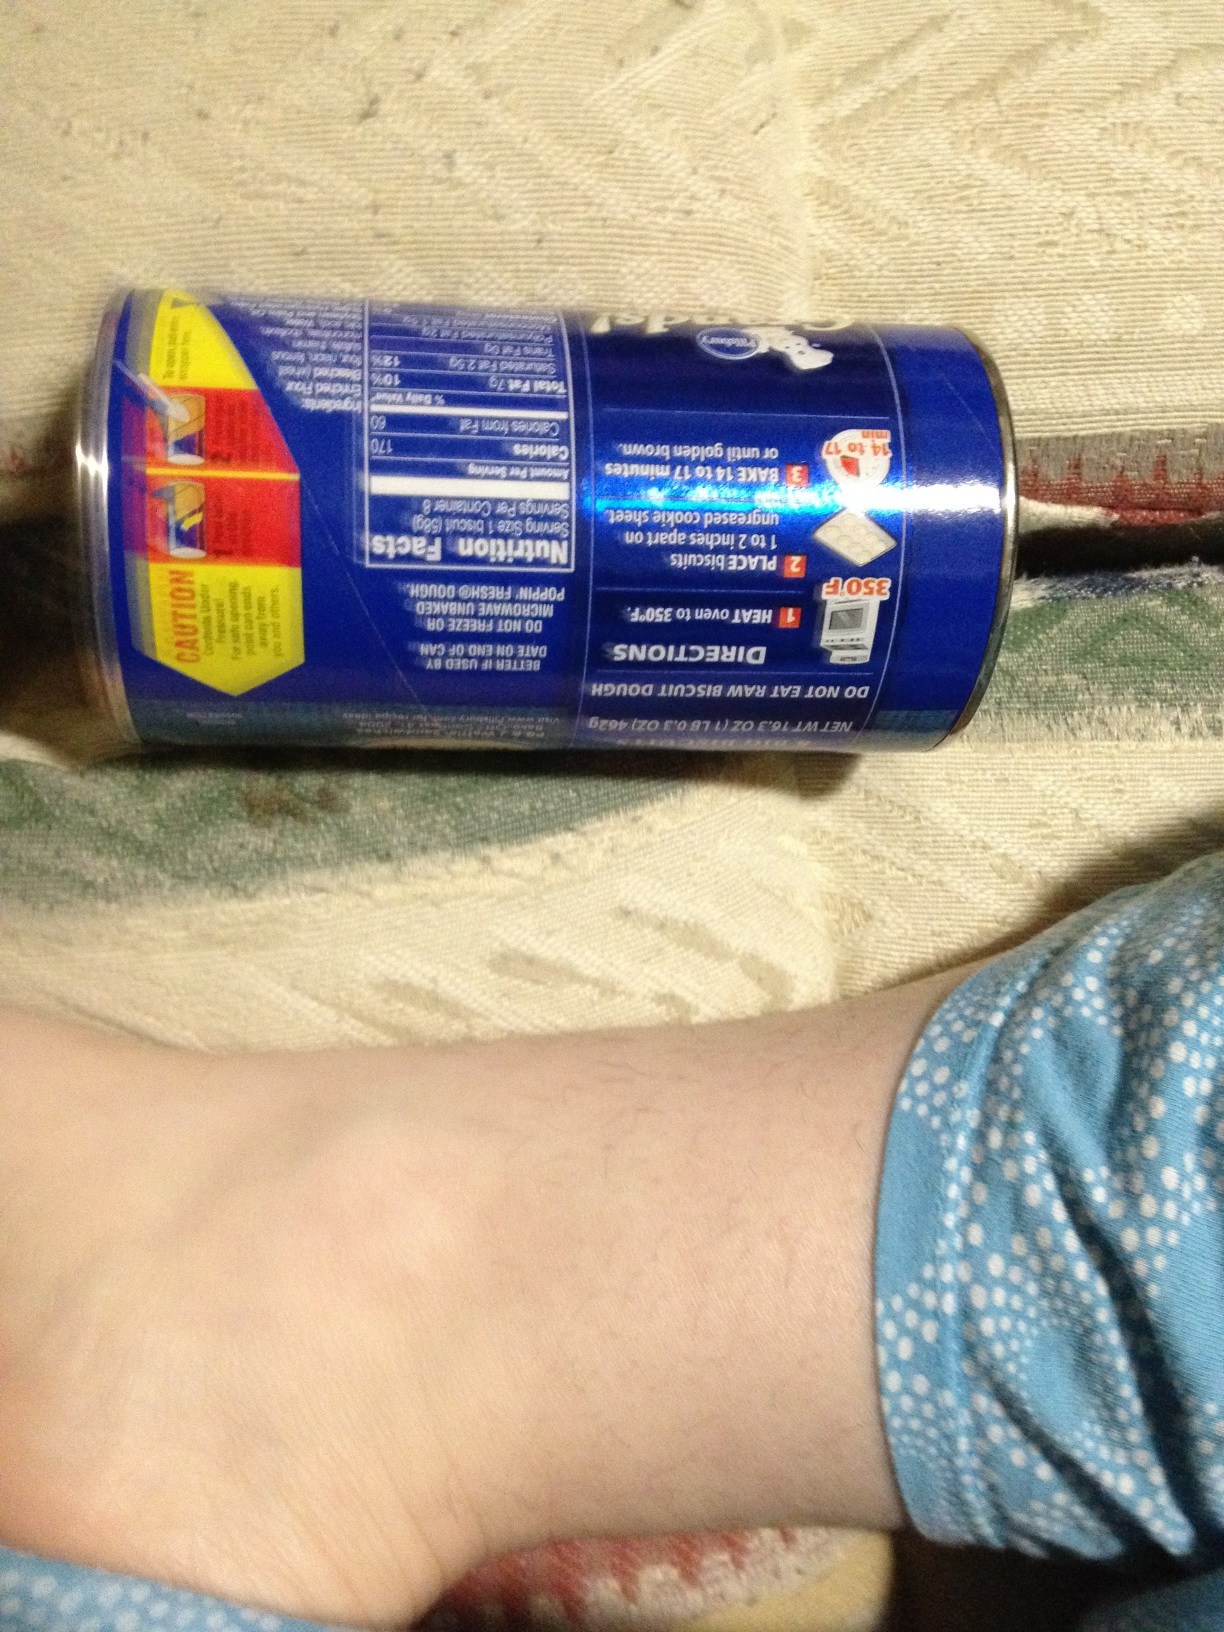What flavor biscuits are these? To determine the flavor of these biscuits, it is necessary to see the front of the can where the main label is typically displayed. The back only provides nutritional information and instructions. 